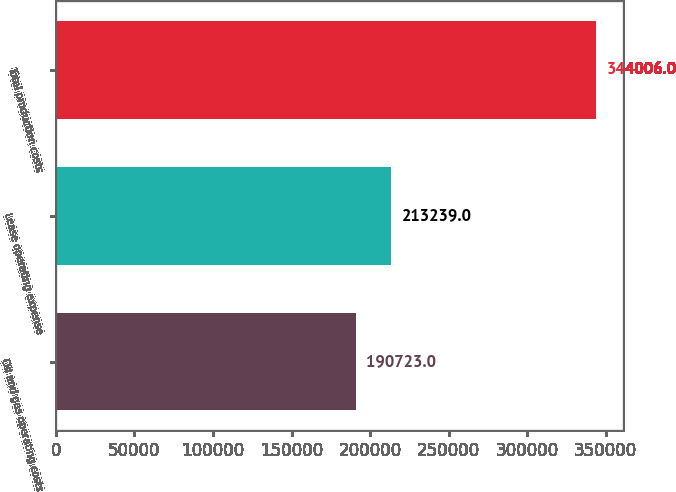Convert chart to OTSL. <chart><loc_0><loc_0><loc_500><loc_500><bar_chart><fcel>Oil and gas operating costs<fcel>Lease operating expense<fcel>Total production costs<nl><fcel>190723<fcel>213239<fcel>344006<nl></chart> 